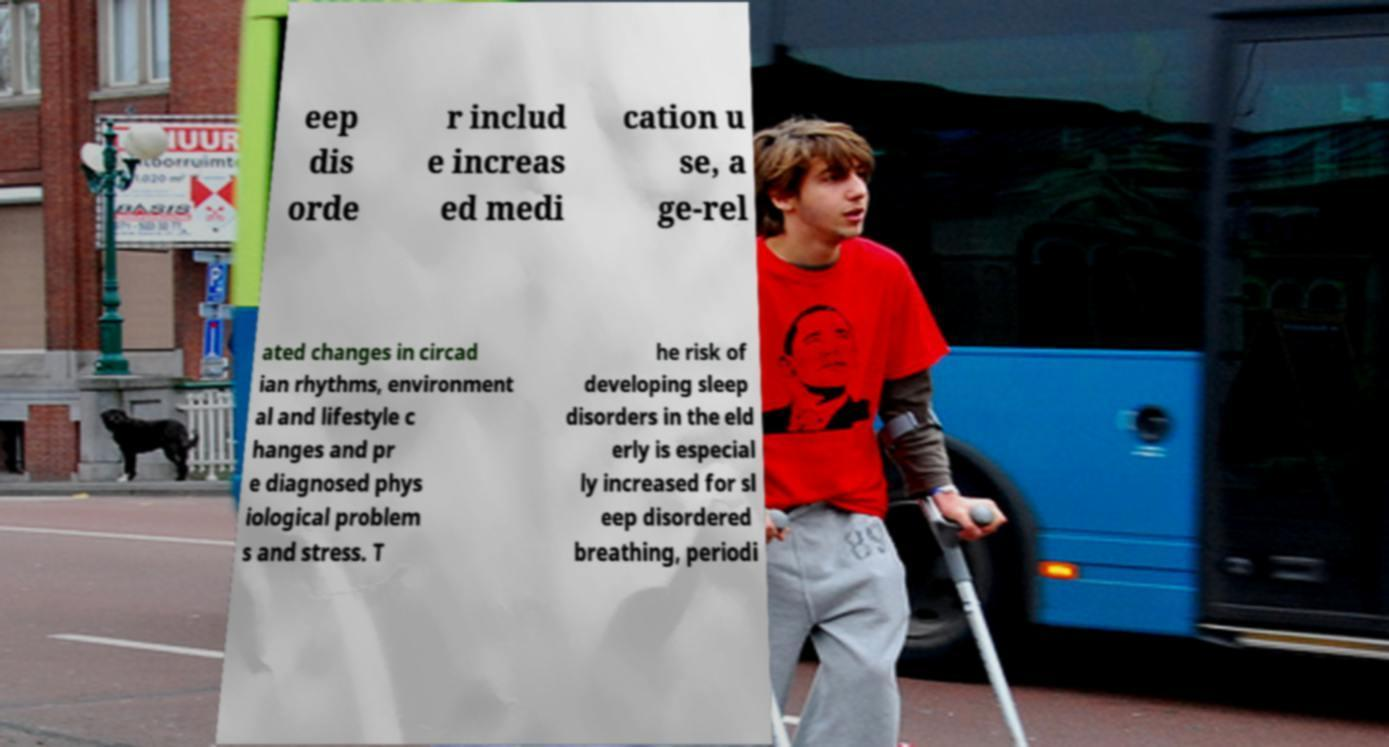For documentation purposes, I need the text within this image transcribed. Could you provide that? eep dis orde r includ e increas ed medi cation u se, a ge-rel ated changes in circad ian rhythms, environment al and lifestyle c hanges and pr e diagnosed phys iological problem s and stress. T he risk of developing sleep disorders in the eld erly is especial ly increased for sl eep disordered breathing, periodi 